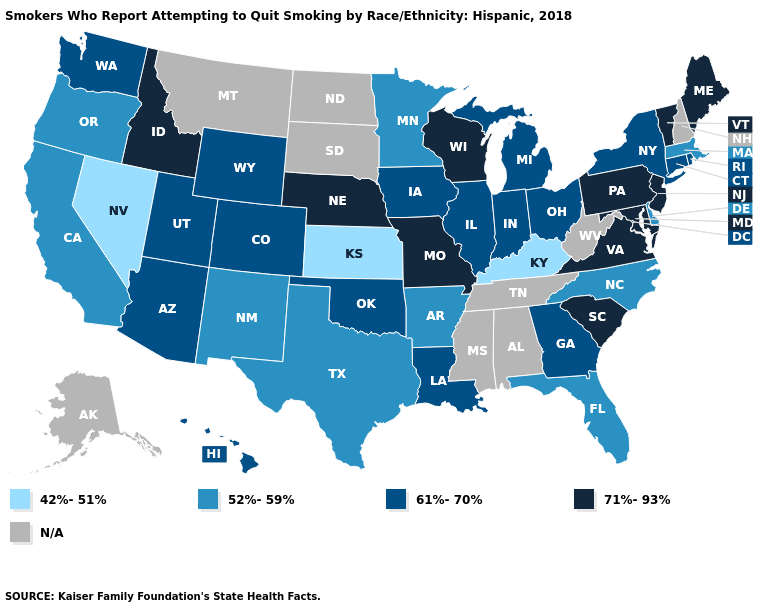What is the highest value in states that border Michigan?
Quick response, please. 71%-93%. Name the states that have a value in the range 42%-51%?
Short answer required. Kansas, Kentucky, Nevada. Does Wisconsin have the highest value in the MidWest?
Quick response, please. Yes. Which states hav the highest value in the Northeast?
Give a very brief answer. Maine, New Jersey, Pennsylvania, Vermont. Name the states that have a value in the range 61%-70%?
Give a very brief answer. Arizona, Colorado, Connecticut, Georgia, Hawaii, Illinois, Indiana, Iowa, Louisiana, Michigan, New York, Ohio, Oklahoma, Rhode Island, Utah, Washington, Wyoming. Does Iowa have the highest value in the USA?
Keep it brief. No. What is the lowest value in the USA?
Short answer required. 42%-51%. Which states have the highest value in the USA?
Concise answer only. Idaho, Maine, Maryland, Missouri, Nebraska, New Jersey, Pennsylvania, South Carolina, Vermont, Virginia, Wisconsin. Does the map have missing data?
Write a very short answer. Yes. Name the states that have a value in the range 52%-59%?
Write a very short answer. Arkansas, California, Delaware, Florida, Massachusetts, Minnesota, New Mexico, North Carolina, Oregon, Texas. What is the highest value in states that border Virginia?
Give a very brief answer. 71%-93%. Name the states that have a value in the range 52%-59%?
Give a very brief answer. Arkansas, California, Delaware, Florida, Massachusetts, Minnesota, New Mexico, North Carolina, Oregon, Texas. What is the value of Hawaii?
Write a very short answer. 61%-70%. 